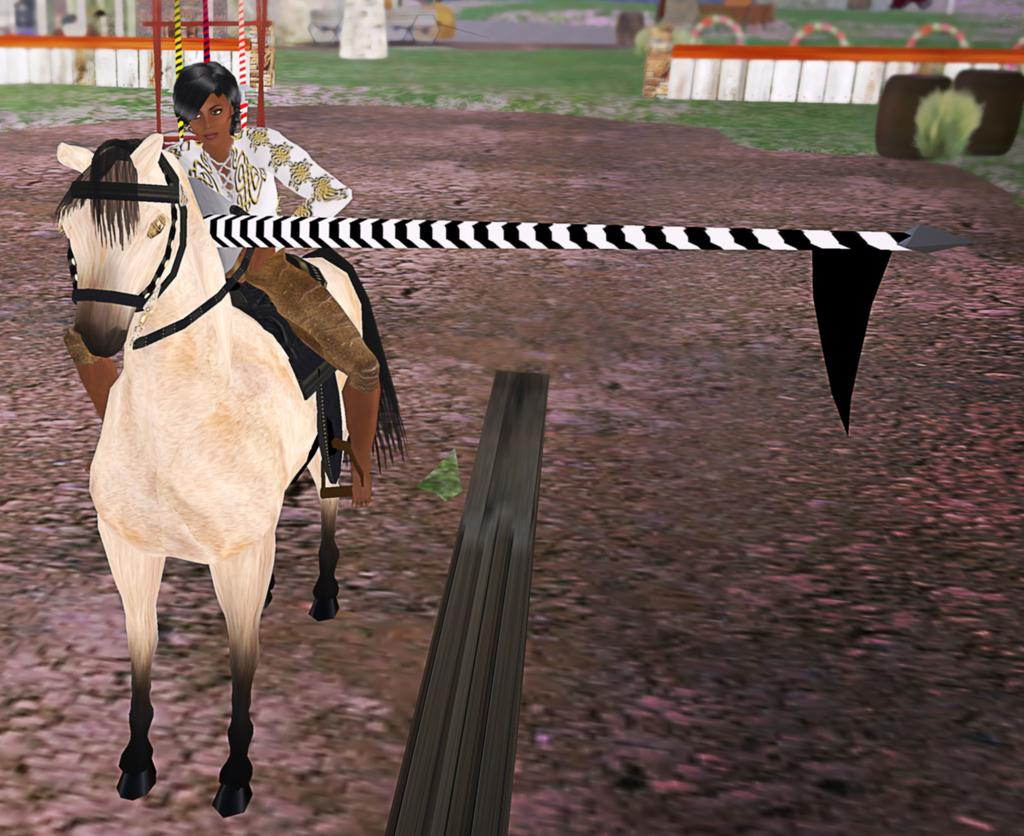Who is in the image? There is a woman in the image. What is the woman doing in the image? The woman is sitting on a horse. What is the position of the horse in the image? The horse is on the ground. What can be seen in the background of the image? There is a flag and fences in the image. What other objects are present in the image? There are rods and other objects in the image. What type of record is being played in the image? There is no record present in the image; it features a woman sitting on a horse. How many spiders are visible on the horse in the image? There are no spiders visible on the horse in the image. 